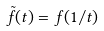Convert formula to latex. <formula><loc_0><loc_0><loc_500><loc_500>\tilde { f } ( t ) = f ( 1 / t )</formula> 